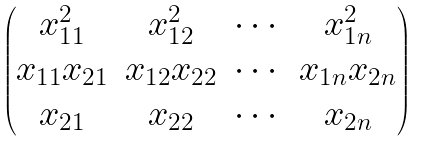<formula> <loc_0><loc_0><loc_500><loc_500>\begin{pmatrix} x _ { 1 1 } ^ { 2 } & x _ { 1 2 } ^ { 2 } & \cdots & x _ { 1 n } ^ { 2 } \\ x _ { 1 1 } x _ { 2 1 } & x _ { 1 2 } x _ { 2 2 } & \cdots & x _ { 1 n } x _ { 2 n } \\ x _ { 2 1 } & x _ { 2 2 } & \cdots & x _ { 2 n } \end{pmatrix}</formula> 